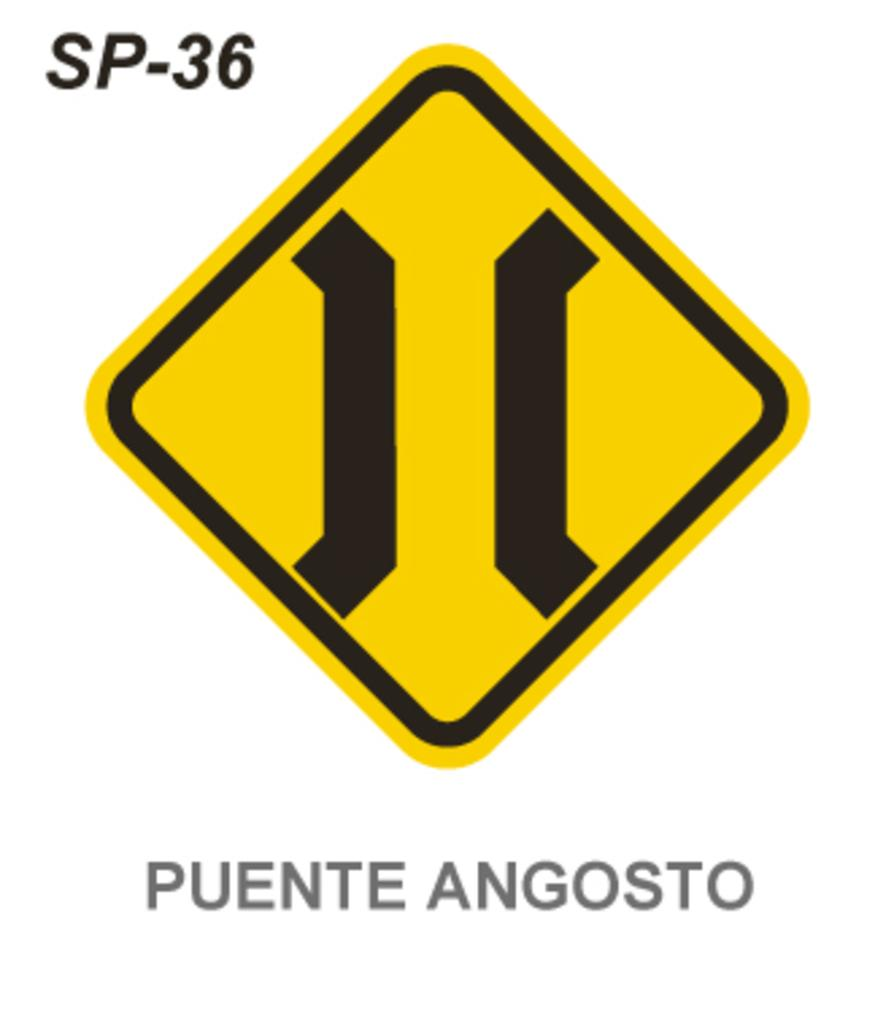Provide a one-sentence caption for the provided image. A black and yellow symbol sign with Puente Angosto written underneath it. 